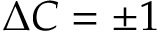Convert formula to latex. <formula><loc_0><loc_0><loc_500><loc_500>\Delta C = \pm 1</formula> 